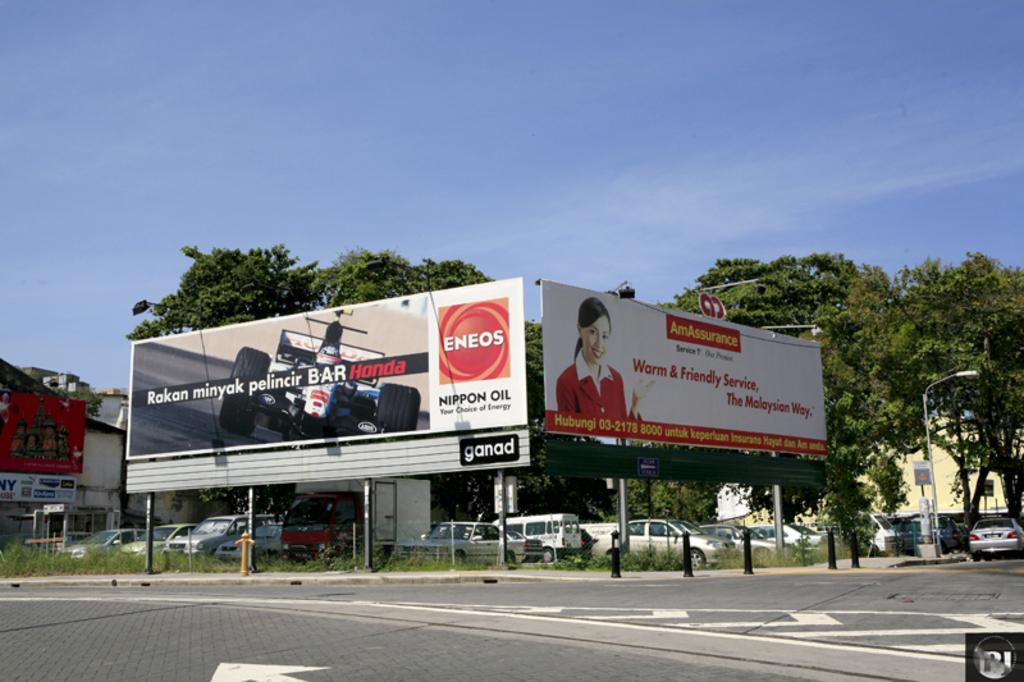<image>
Share a concise interpretation of the image provided. A billboard for Eneos Nippon Oil sits on a corner of a street. 